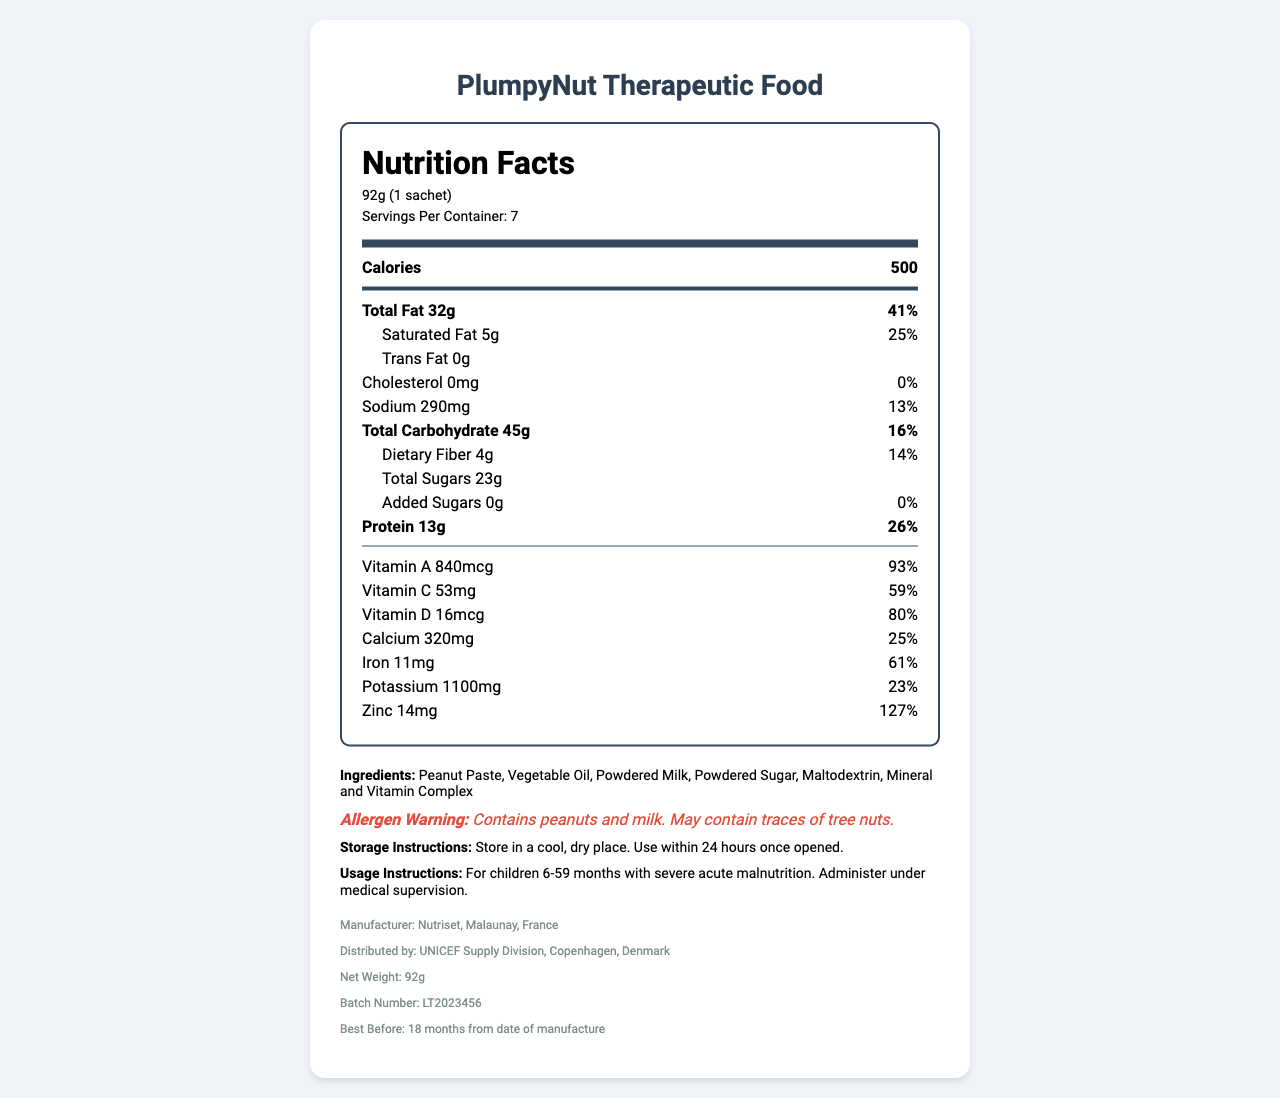what is the total fat content per serving? The total fat content per serving, as stated in the document, is 32g.
Answer: 32g how many calories are there in one sachet? The nutrition facts label lists the calories per serving to be 500, and the serving size is one sachet.
Answer: 500 what is the daily value percentage of Vitamin A per serving? The daily value percentage of Vitamin A per serving is listed as 93%.
Answer: 93% what are the storage instructions for the product? The storage instructions are clearly stated in the document under the "Storage Instructions" section.
Answer: Store in a cool, dry place. Use within 24 hours once opened. who is the manufacturer of PlumpyNut Therapeutic Food? The manufacturer information provided at the end of the document specifies that Nutriset, located in Malaunay, France, is the manufacturer.
Answer: Nutriset, Malaunay, France what is the serving size of this product? The serving size is listed as 92g, which is equivalent to one sachet.
Answer: 92g (1 sachet) what is the amount of dietary fiber per serving? The dietary fiber content per serving is listed as 4g.
Answer: 4g does this product contain added sugars? The label specifies that the amount of added sugars is 0g, indicating the product does not contain added sugars.
Answer: No, 0g what is the expiration date of the product? The expiration date listed at the end of the document specifies that the product is best before 18 months from the date of manufacture.
Answer: 18 months from date of manufacture what is the sodium content per serving? The sodium content per serving is stated to be 290mg on the nutrition label.
Answer: 290mg which of the following is the highest percentage of daily value for a nutrient per serving? A. Vitamin A B. Vitamin C C. Zinc D. Calcium Zinc has the highest daily value percentage per serving, which is 127%.
Answer: C. Zinc how many grams of protein are there per serving? The protein content per serving is listed as 13g.
Answer: 13g how many servings are there per container? The nutrition facts label states that there are 7 servings per container.
Answer: 7 what is the correct batch number for this product? The batch number listed at the end of the document is LT2023456.
Answer: LT2023456 does this product contain any trans fat? The document states that the trans fat content is 0g, meaning the product does not contain trans fat.
Answer: No which of these ingredients is not in the product? A. Peanut Paste B. Almond Butter C. Maltodextrin D. Powdered Milk Almond butter is not listed among the ingredients; the listed ingredients include Peanut Paste, Maltodextrin, and Powdered Milk.
Answer: B. Almond Butter is the product suitable for children without medical supervision? The usage instructions indicate that it should be administered under medical supervision for children 6-59 months with severe acute malnutrition.
Answer: No describe the main information contained in the document. The document provides a comprehensive overview of the product, including nutritional content, ingredient list, allergen warnings, and other operational details critical for consumer and medical use.
Answer: The document is a nutritional facts label for PlumpyNut Therapeutic Food, which is intended for children with severe acute malnutrition. It lists detailed nutritional information per serving, serving size, the percentage of daily values, ingredients, allergen warning, storage and usage instructions, manufacturer and distributor details, and other relevant product information. how many calories come from fat? The document lists the total calories per serving and total fat content, but it does not directly provide the number of calories coming from fat.
Answer: Not enough information 